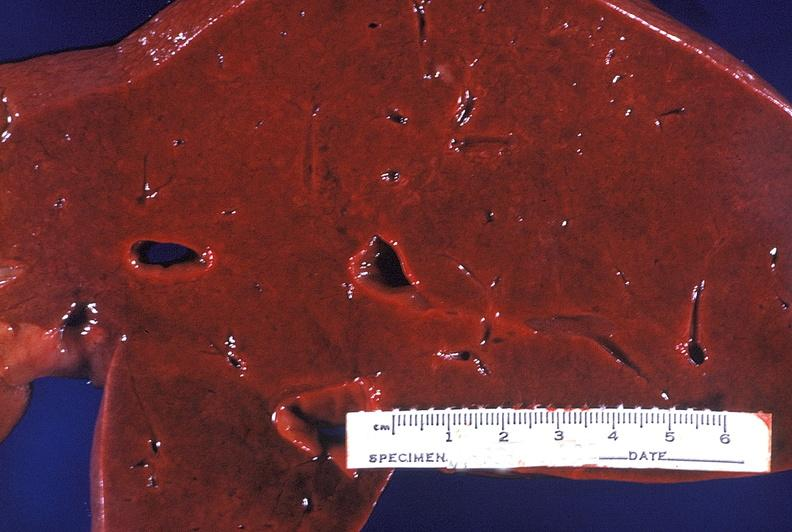what is present?
Answer the question using a single word or phrase. Hepatobiliary 